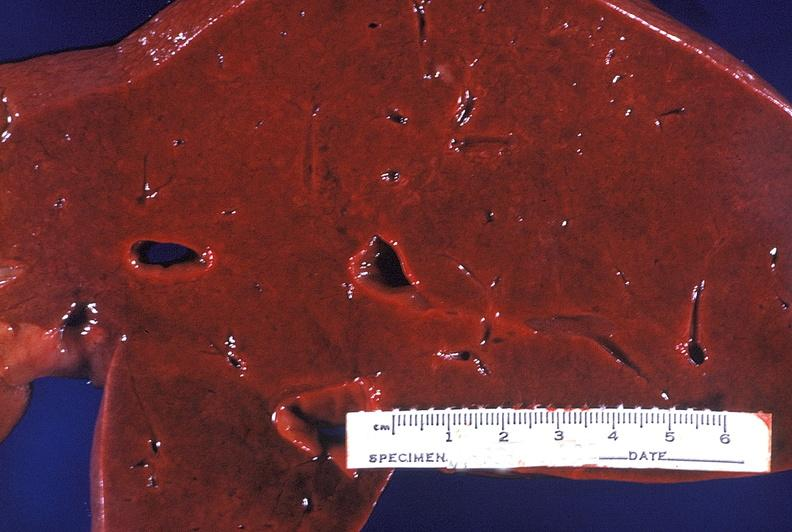what is present?
Answer the question using a single word or phrase. Hepatobiliary 